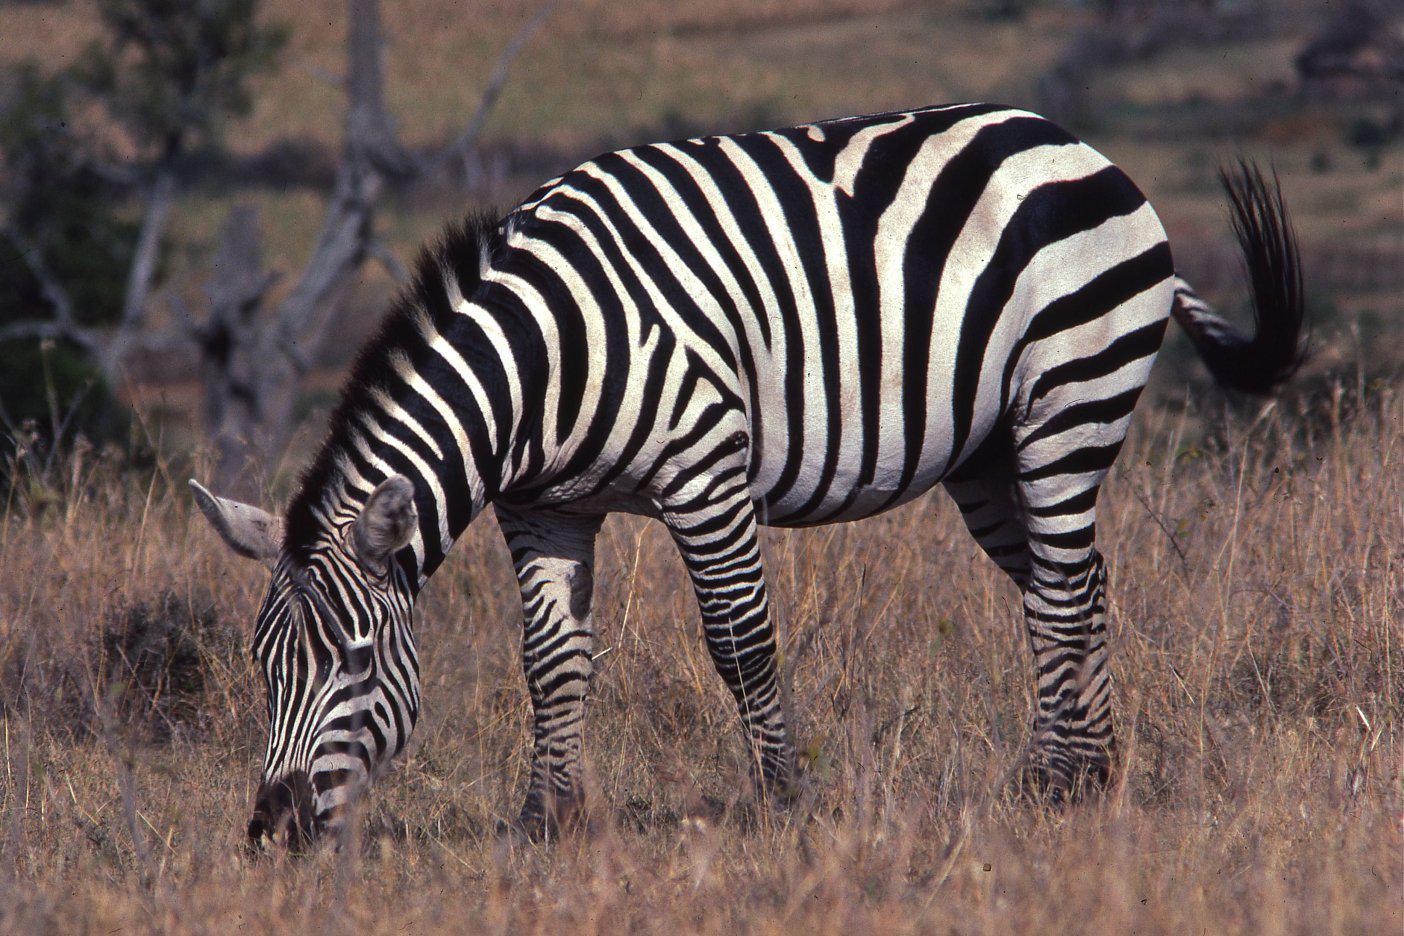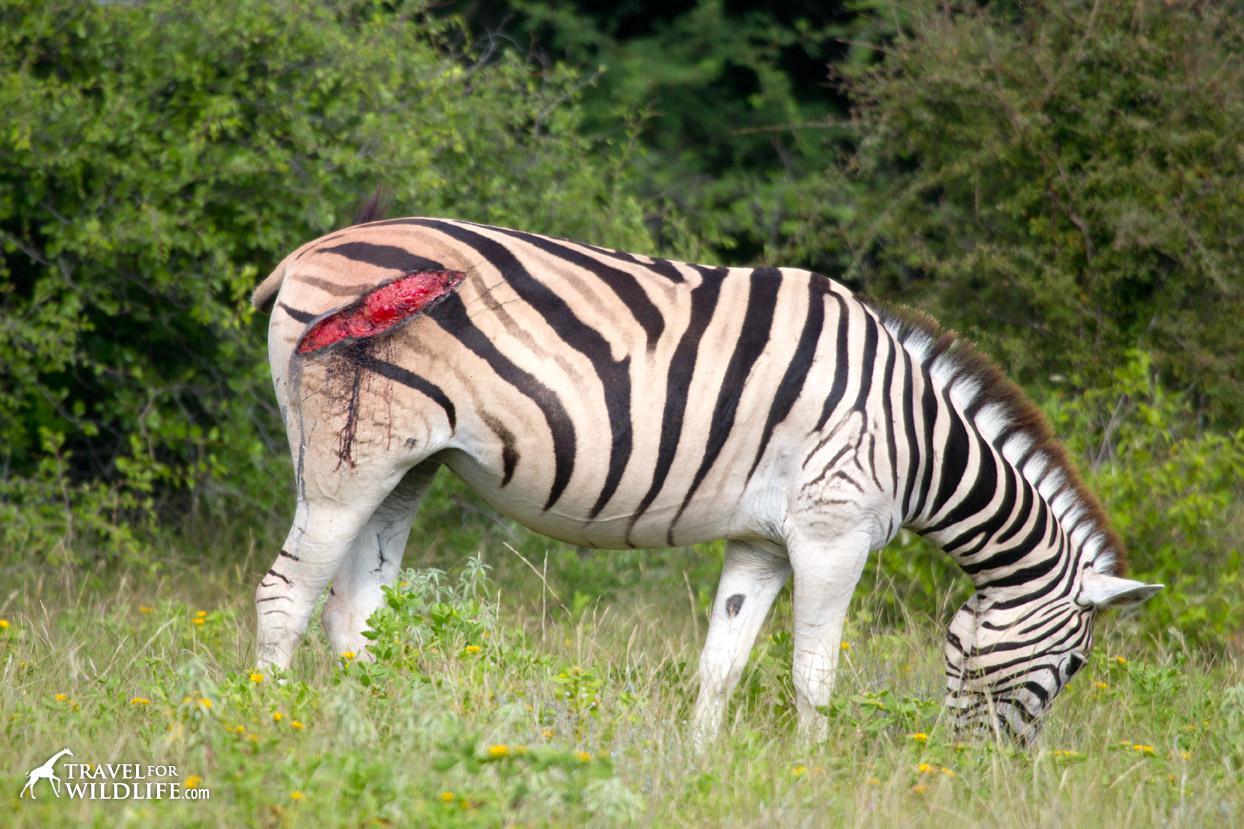The first image is the image on the left, the second image is the image on the right. For the images shown, is this caption "The left image contains one rightward turned standing zebra in profile, with its head bent to the grass, and the right image includes an adult standing leftward-turned zebra with one back hoof raised." true? Answer yes or no. No. The first image is the image on the left, the second image is the image on the right. For the images shown, is this caption "The right image contains two zebras." true? Answer yes or no. No. 